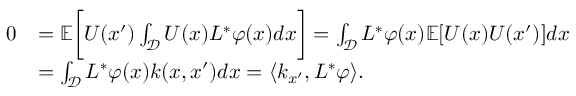<formula> <loc_0><loc_0><loc_500><loc_500>\begin{array} { r l } { 0 } & { = \mathbb { E } \left [ U ( x ^ { \prime } ) \int _ { \mathcal { D } } U ( x ) L ^ { * } \varphi ( x ) d x \right ] = \int _ { \mathcal { D } } L ^ { * } \varphi ( x ) \mathbb { E } [ U ( x ) U ( x ^ { \prime } ) ] d x } \\ & { = \int _ { \mathcal { D } } L ^ { * } \varphi ( x ) k ( x , x ^ { \prime } ) d x = \langle k _ { x ^ { \prime } } , L ^ { * } \varphi \rangle . } \end{array}</formula> 